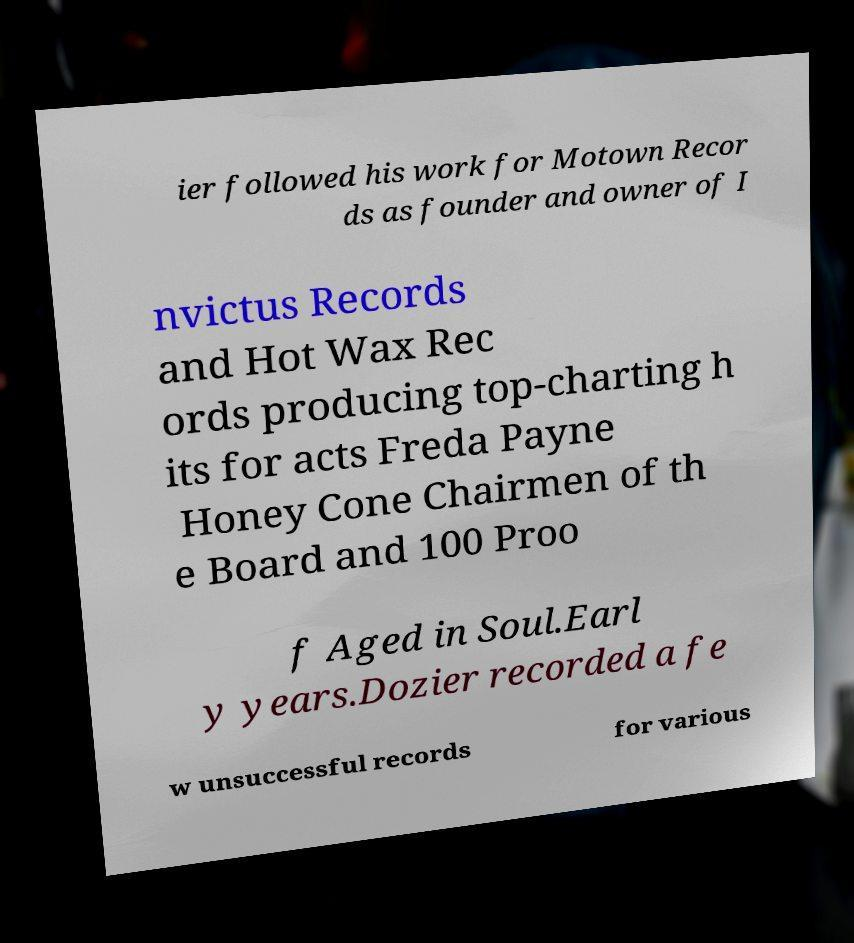Please identify and transcribe the text found in this image. ier followed his work for Motown Recor ds as founder and owner of I nvictus Records and Hot Wax Rec ords producing top-charting h its for acts Freda Payne Honey Cone Chairmen of th e Board and 100 Proo f Aged in Soul.Earl y years.Dozier recorded a fe w unsuccessful records for various 